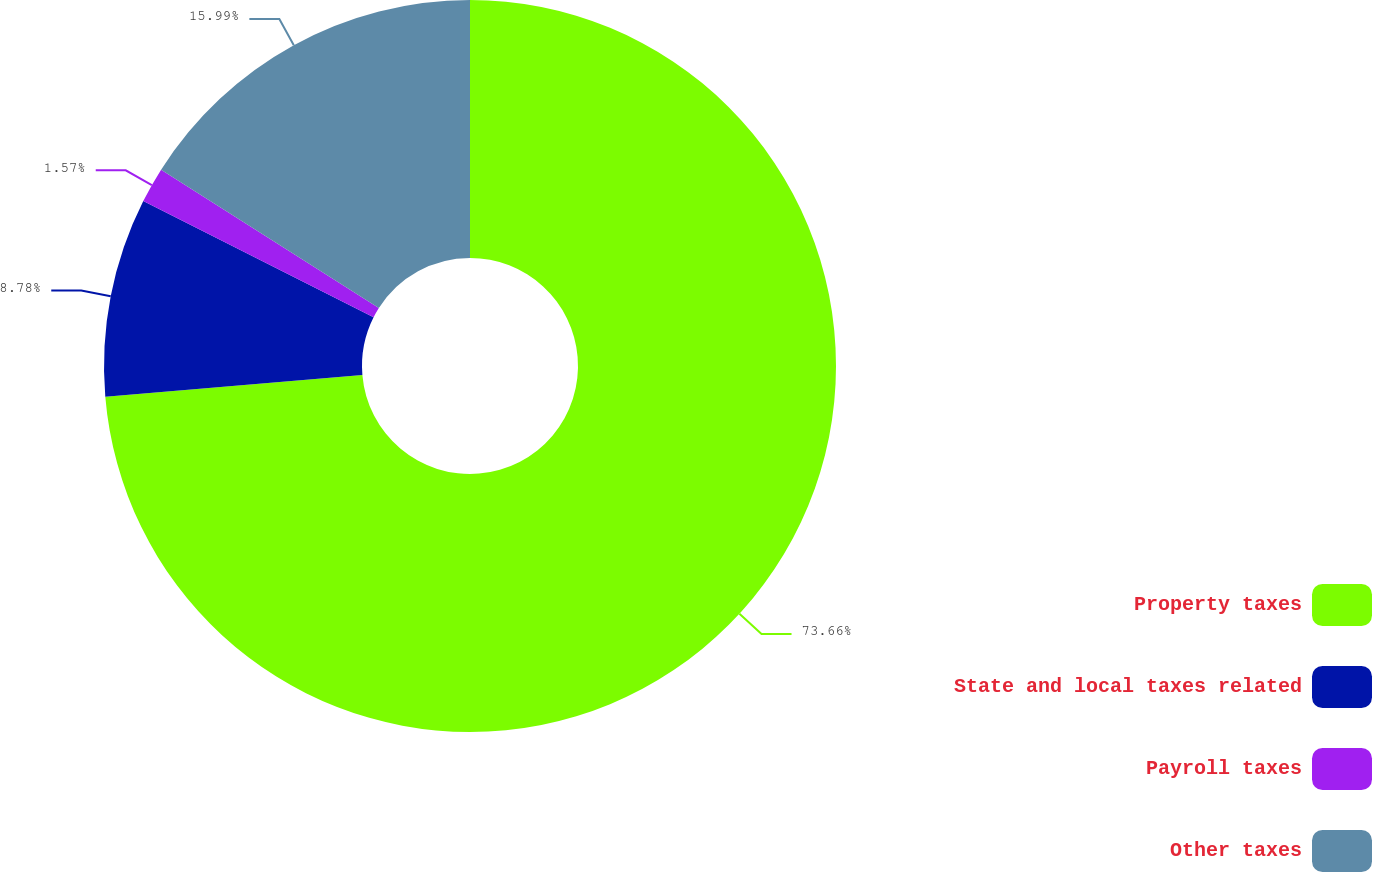<chart> <loc_0><loc_0><loc_500><loc_500><pie_chart><fcel>Property taxes<fcel>State and local taxes related<fcel>Payroll taxes<fcel>Other taxes<nl><fcel>73.67%<fcel>8.78%<fcel>1.57%<fcel>15.99%<nl></chart> 